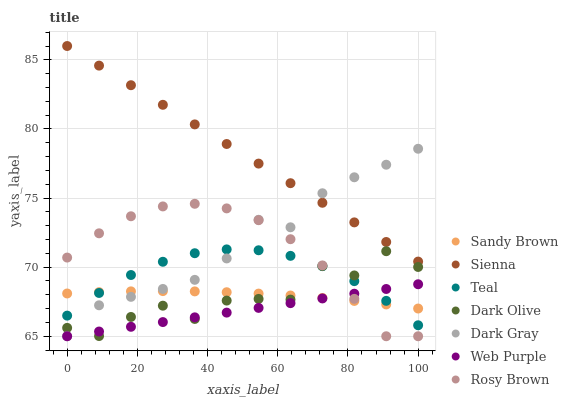Does Web Purple have the minimum area under the curve?
Answer yes or no. Yes. Does Sienna have the maximum area under the curve?
Answer yes or no. Yes. Does Rosy Brown have the minimum area under the curve?
Answer yes or no. No. Does Rosy Brown have the maximum area under the curve?
Answer yes or no. No. Is Sienna the smoothest?
Answer yes or no. Yes. Is Dark Olive the roughest?
Answer yes or no. Yes. Is Rosy Brown the smoothest?
Answer yes or no. No. Is Rosy Brown the roughest?
Answer yes or no. No. Does Dark Gray have the lowest value?
Answer yes or no. Yes. Does Dark Olive have the lowest value?
Answer yes or no. No. Does Sienna have the highest value?
Answer yes or no. Yes. Does Rosy Brown have the highest value?
Answer yes or no. No. Is Sandy Brown less than Sienna?
Answer yes or no. Yes. Is Sienna greater than Sandy Brown?
Answer yes or no. Yes. Does Web Purple intersect Dark Olive?
Answer yes or no. Yes. Is Web Purple less than Dark Olive?
Answer yes or no. No. Is Web Purple greater than Dark Olive?
Answer yes or no. No. Does Sandy Brown intersect Sienna?
Answer yes or no. No. 